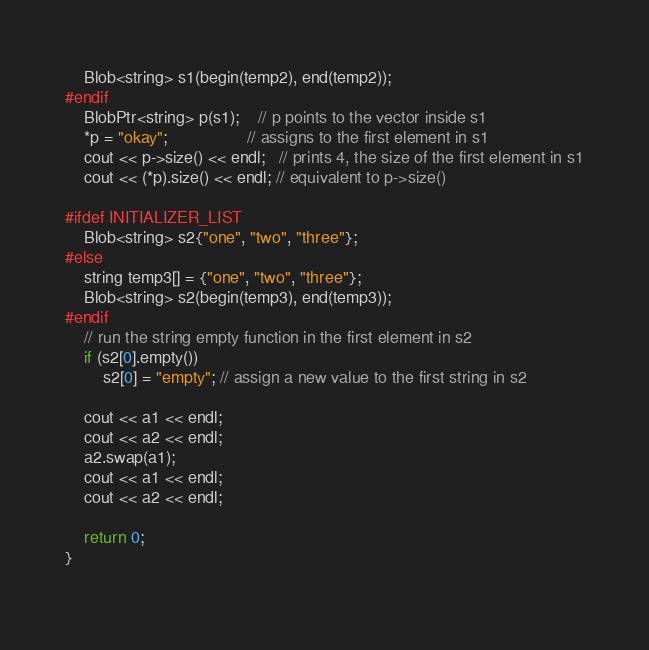Convert code to text. <code><loc_0><loc_0><loc_500><loc_500><_C++_>	Blob<string> s1(begin(temp2), end(temp2));
#endif
	BlobPtr<string> p(s1);    // p points to the vector inside s1
	*p = "okay";                 // assigns to the first element in s1
	cout << p->size() << endl;   // prints 4, the size of the first element in s1
	cout << (*p).size() << endl; // equivalent to p->size()
	
#ifdef INITIALIZER_LIST
	Blob<string> s2{"one", "two", "three"};
#else
	string temp3[] = {"one", "two", "three"};
	Blob<string> s2(begin(temp3), end(temp3));
#endif
	// run the string empty function in the first element in s2
	if (s2[0].empty())   
	    s2[0] = "empty"; // assign a new value to the first string in s2
	
	cout << a1 << endl;
	cout << a2 << endl;
	a2.swap(a1);
	cout << a1 << endl;
	cout << a2 << endl;

	return 0;
}
	
</code> 